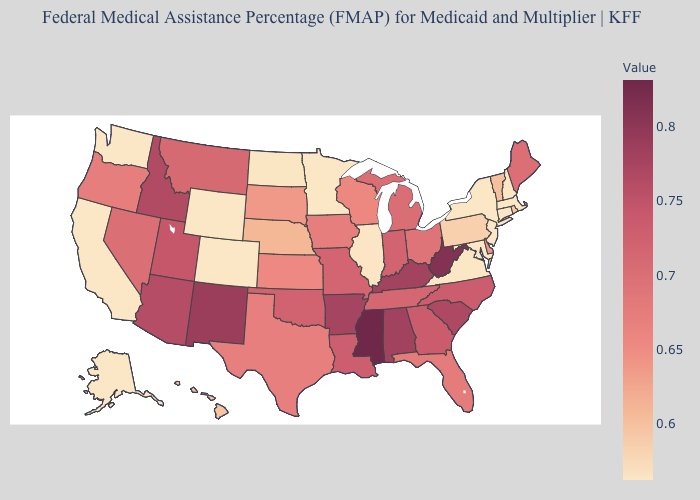Among the states that border Montana , which have the lowest value?
Short answer required. Wyoming. Does Minnesota have the lowest value in the MidWest?
Quick response, please. Yes. Does New Mexico have the highest value in the West?
Keep it brief. Yes. Among the states that border New Hampshire , which have the highest value?
Answer briefly. Maine. Does the map have missing data?
Answer briefly. No. Does Kansas have a lower value than Mississippi?
Quick response, please. Yes. 